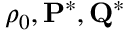<formula> <loc_0><loc_0><loc_500><loc_500>\rho _ { 0 } , { P ^ { * } , Q ^ { * } }</formula> 